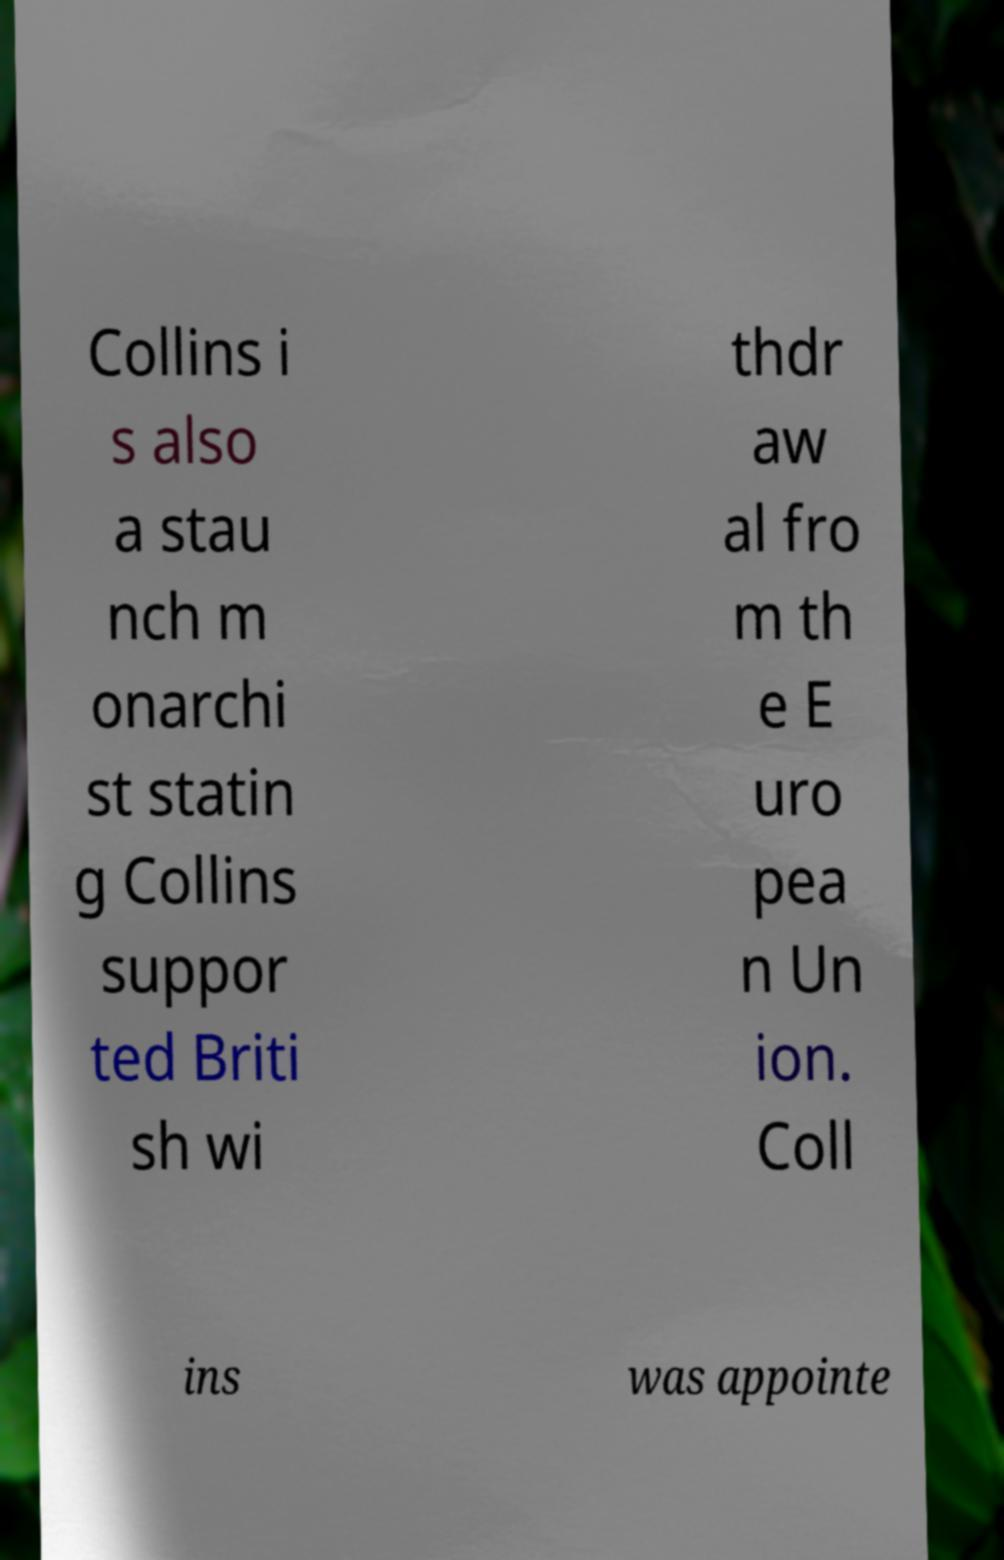Could you assist in decoding the text presented in this image and type it out clearly? Collins i s also a stau nch m onarchi st statin g Collins suppor ted Briti sh wi thdr aw al fro m th e E uro pea n Un ion. Coll ins was appointe 